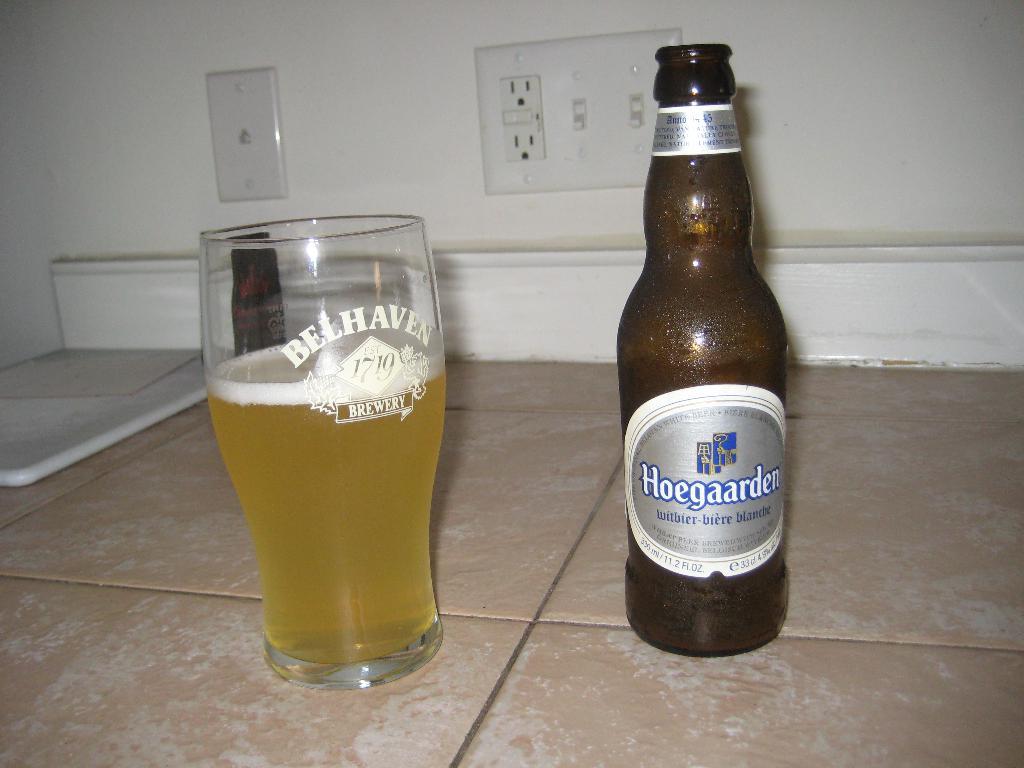Who makes this beer?
Keep it short and to the point. Hoegaarden. How many ounces is the beer?
Provide a short and direct response. 11.2. 